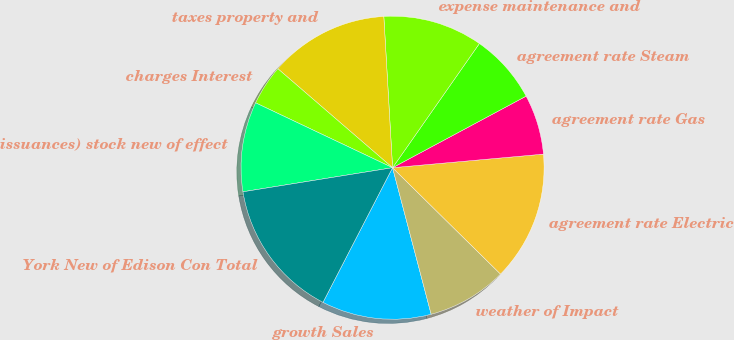<chart> <loc_0><loc_0><loc_500><loc_500><pie_chart><fcel>growth Sales<fcel>weather of Impact<fcel>agreement rate Electric<fcel>agreement rate Gas<fcel>agreement rate Steam<fcel>expense maintenance and<fcel>taxes property and<fcel>charges Interest<fcel>issuances) stock new of effect<fcel>York New of Edison Con Total<nl><fcel>11.69%<fcel>8.52%<fcel>13.81%<fcel>6.4%<fcel>7.46%<fcel>10.63%<fcel>12.75%<fcel>4.29%<fcel>9.58%<fcel>14.87%<nl></chart> 